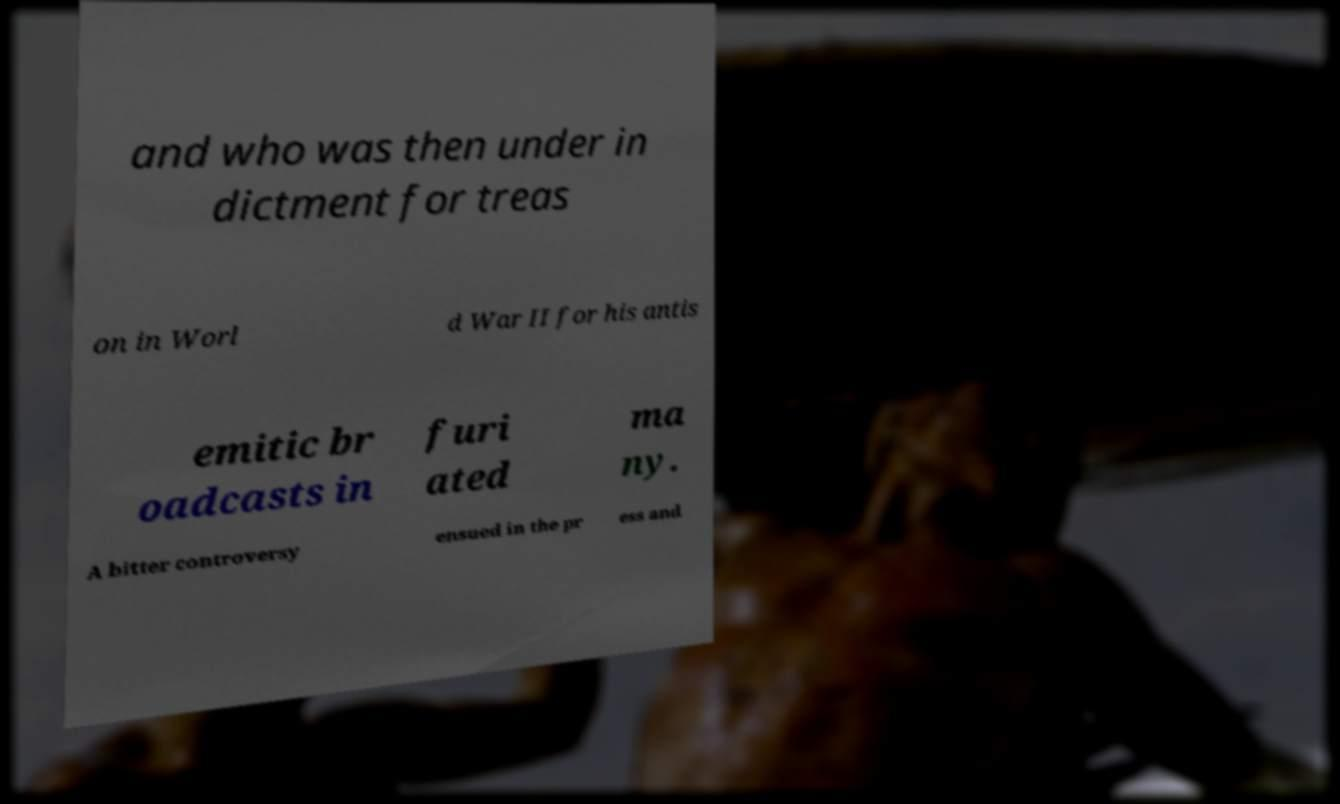What messages or text are displayed in this image? I need them in a readable, typed format. and who was then under in dictment for treas on in Worl d War II for his antis emitic br oadcasts in furi ated ma ny. A bitter controversy ensued in the pr ess and 